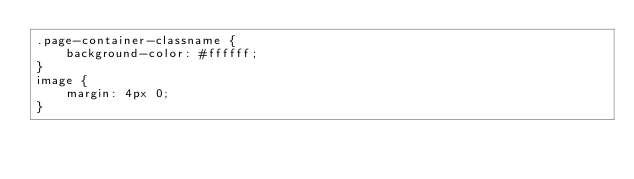<code> <loc_0><loc_0><loc_500><loc_500><_CSS_>.page-container-classname {
    background-color: #ffffff;
}
image {
    margin: 4px 0;
}
</code> 